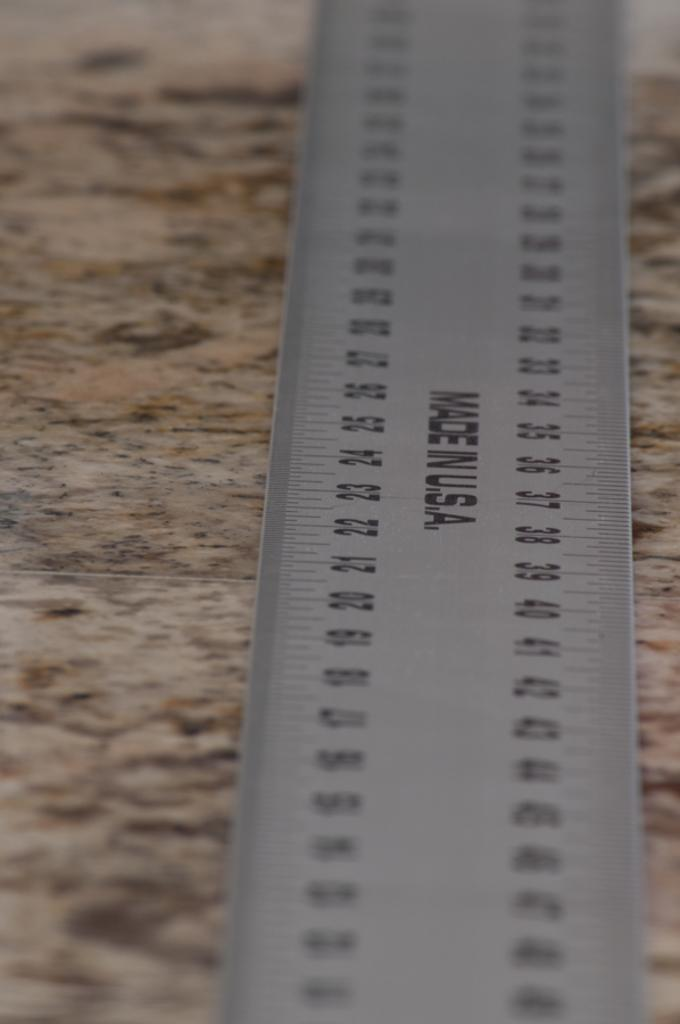<image>
Present a compact description of the photo's key features. A silver ruler that says Made In U.S.A. is on a granite counter. 